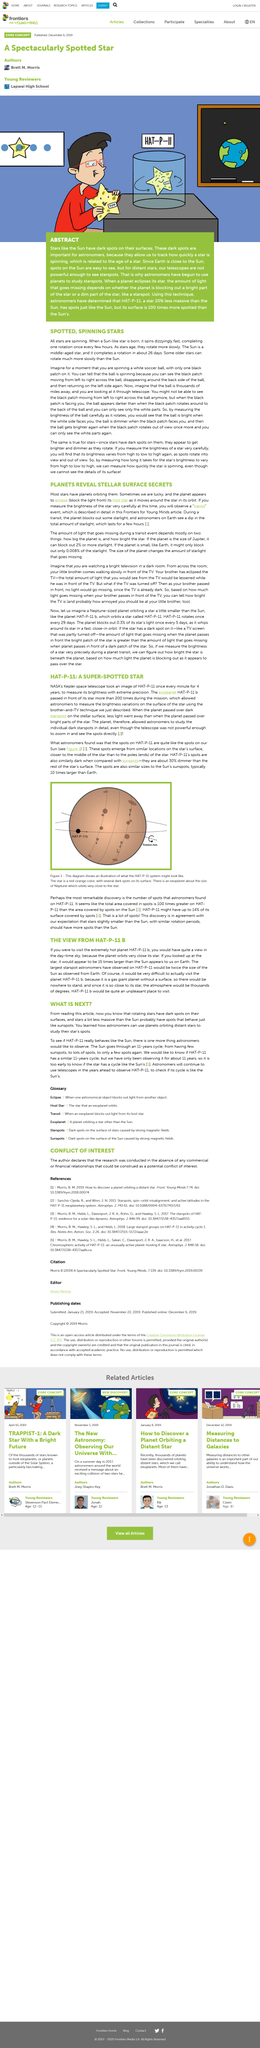Highlight a few significant elements in this photo. The NASA's Kepler space telescope took images of HAT-P-11 to determine its brightness with exceptional accuracy. Astronomers have discovered that the spots on the Sun are similar to those on HAT-P-11, a distant exoplanet. When a sun-like star is born, it rapidly rotates, completing one rotation every few hours. A planet eclipse occurs when a planet passes in front of its host star, blocking the light from the star as it moves around the star in its orbit. Jupiter is the planet that can block out 2% or more of starlight. 